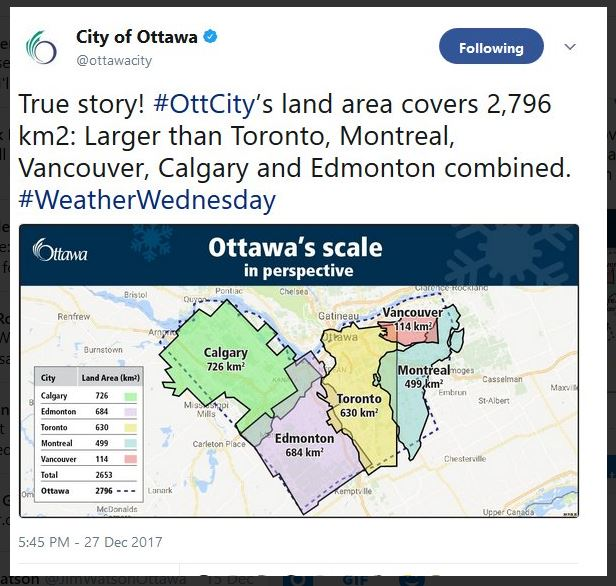How might the larger land area of Ottawa contribute to its economic development? Ottawa's substantial land area can greatly contribute to its economic development. With more space available, the city can host a variety of businesses, from technology startups to large manufacturing plants. The ample land allows for the creation of business parks and innovation hubs, attracting investment and fostering job creation. Agricultural activities could also thrive, supporting local food production and sustainability initiatives. Additionally, larger areas for residential development can accommodate a growing population, leading to increased consumer demand and further economic growth. 